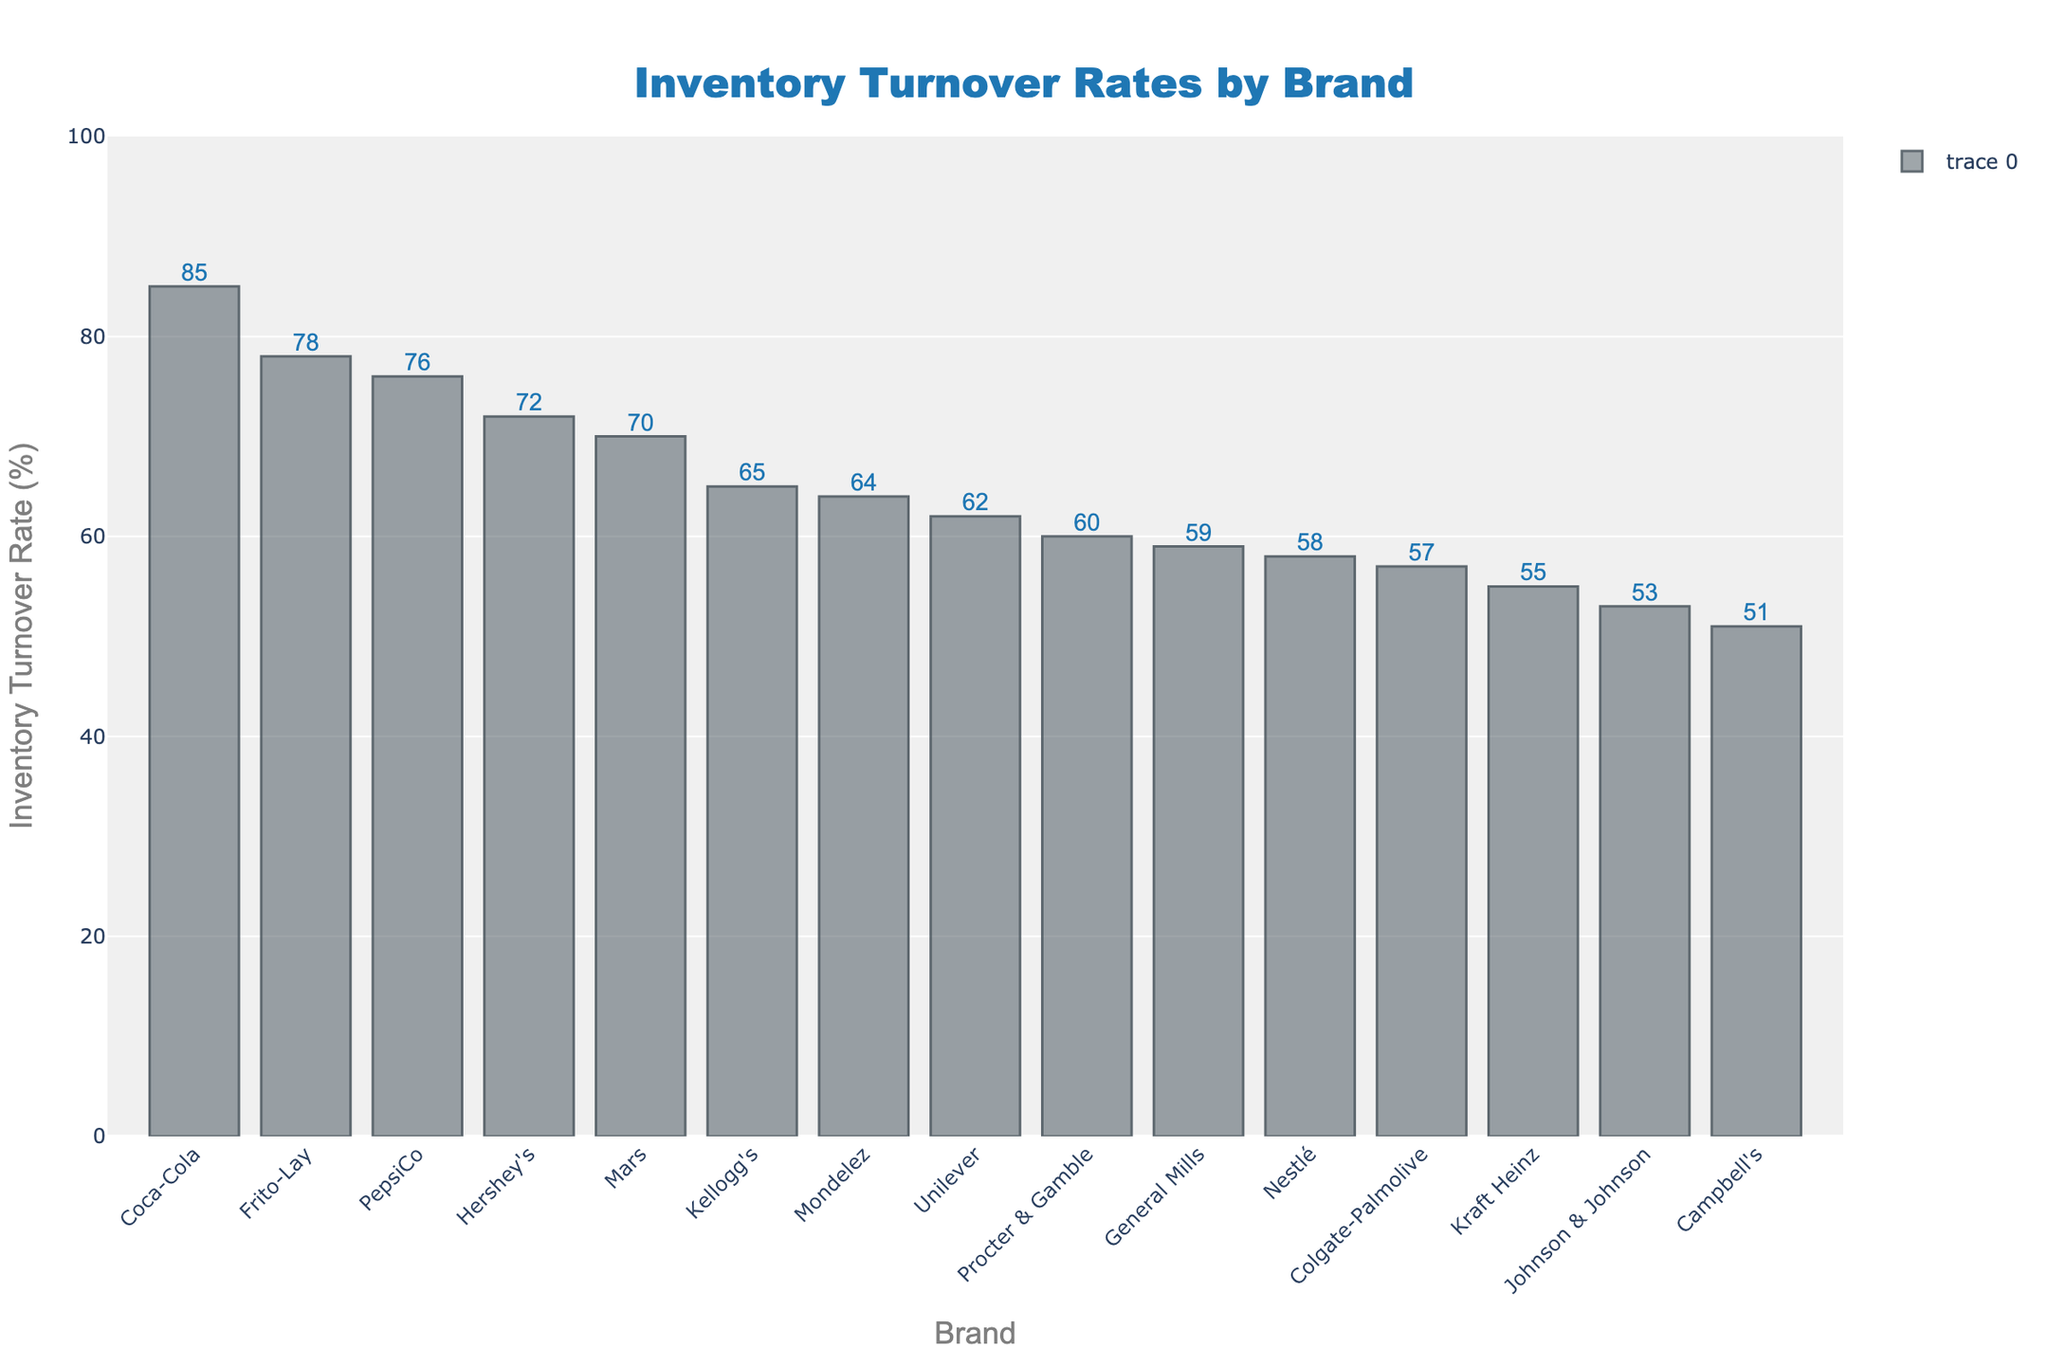Which brand has the highest inventory turnover rate? The bar representing Coca-Cola is the tallest in the chart, indicating it has the highest inventory turnover rate.
Answer: Coca-Cola Which brands have inventory turnover rates greater than 70%? The bars for Coca-Cola, Frito-Lay, PepsiCo, and Hershey's exceed the 70% mark.
Answer: Coca-Cola, Frito-Lay, PepsiCo, Hershey's How many brands have an inventory turnover rate below 60%? Count the number of brands where the bars' heights do not reach the 60% mark. These are Campbell's, Johnson & Johnson, Kraft Heinz, Colgate-Palmolive, General Mills, and Nestlé.
Answer: 6 Which brand has the lowest inventory turnover rate? The shortest bar in the chart represents Campbell's, indicating it has the lowest turnover rate.
Answer: Campbell's Compare the inventory turnover rates of Unilever and Mondelez. Which is higher? The bars for Unilever and Mondelez indicate their rates are 62% and 64%, respectively. Mondelez's bar is taller.
Answer: Mondelez What is the average inventory turnover rate of the top three brands? The turnover rates for Coca-Cola, Frito-Lay, and PepsiCo are 85%, 78%, and 76% respectively. The sum is 85 + 78 + 76 = 239. The average is 239/3 = 79.67.
Answer: 79.67% What are the inventory turnover rates for Colgate-Palmolive and General Mills? The bar heights indicate Colgate-Palmolive has a turnover rate of 57%, and General Mills has a turnover rate of 59%.
Answer: 57% and 59% By how much does Hershey's inventory turnover rate exceed that of Procter & Gamble? Hershey's rate is 72%, and Procter & Gamble's rate is 60%. The difference is 72 - 60 = 12.
Answer: 12% Which brand is immediately below Mars in terms of inventory turnover rate? The bar heights indicate Mondelez is just below Mars, with Mars at 70% and Mondelez at 64%.
Answer: Mondelez What is the median inventory turnover rate of all the brands? List the rates in ascending order: 51, 53, 55, 57, 58, 59, 60, 62, 64, 65, 70, 72, 76, 78, 85. The median is the 8th value in the ordered list.
Answer: 62% 